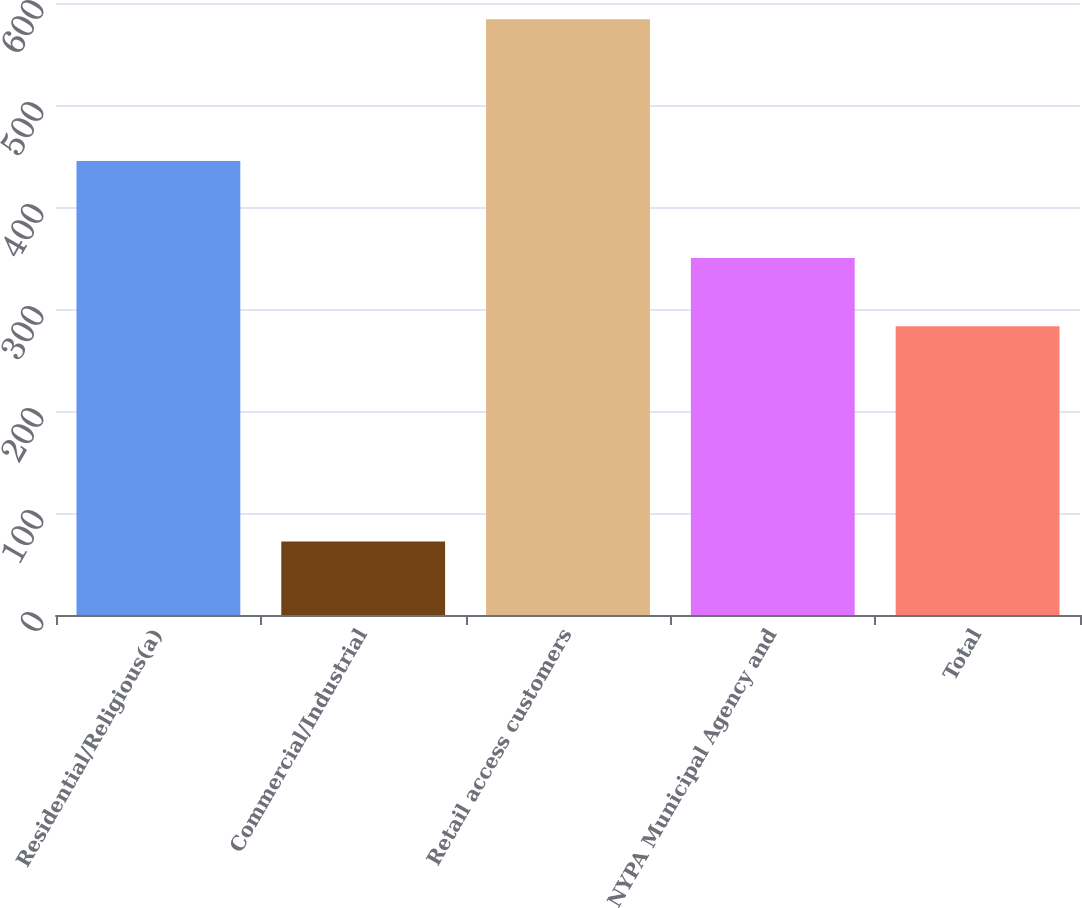Convert chart. <chart><loc_0><loc_0><loc_500><loc_500><bar_chart><fcel>Residential/Religious(a)<fcel>Commercial/Industrial<fcel>Retail access customers<fcel>NYPA Municipal Agency and<fcel>Total<nl><fcel>445<fcel>72<fcel>584<fcel>350<fcel>283<nl></chart> 